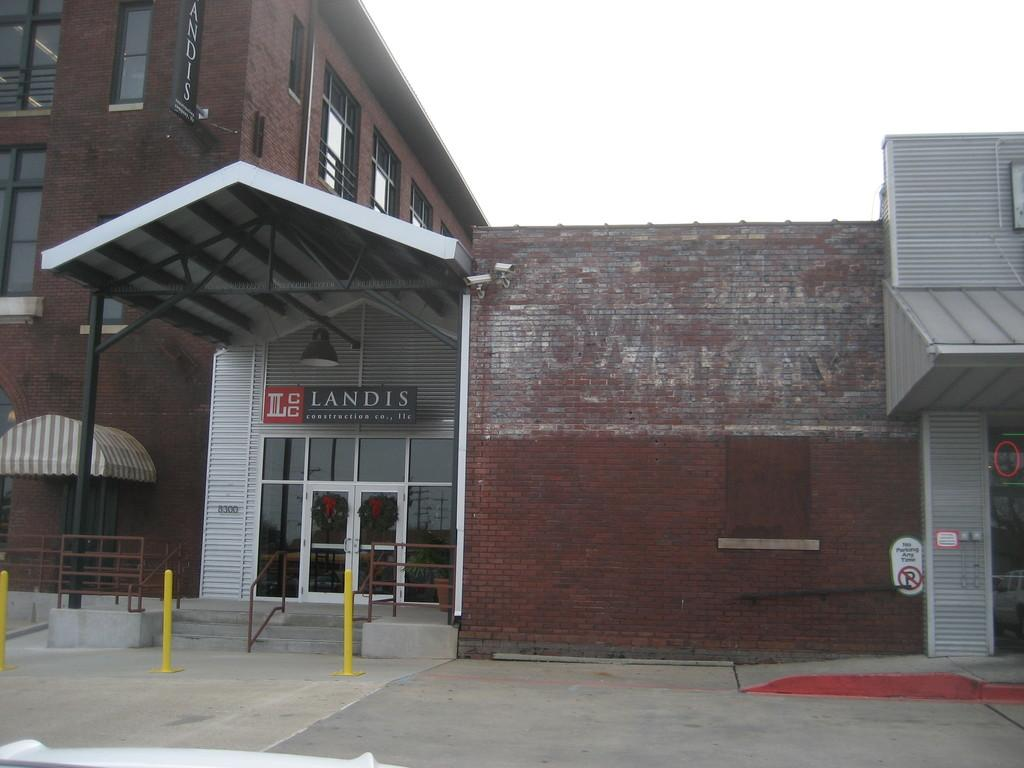What type of structure is visible in the image? There is a building in the image. What is in front of the building? There is a glass door, railing, stairs, and poles in front of the building. What is the color of the sky in the image? The sky is white in color. How many feet of grain can be seen growing near the building in the image? There is no grain visible in the image, and therefore no feet of grain can be measured. 